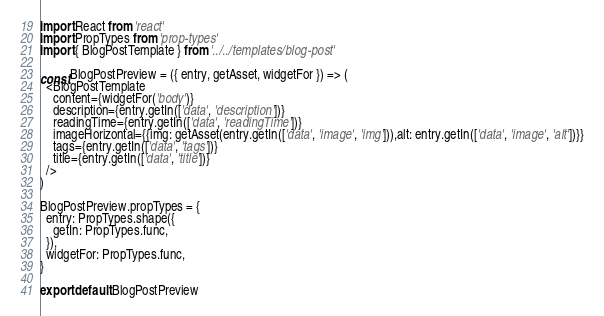<code> <loc_0><loc_0><loc_500><loc_500><_JavaScript_>import React from 'react'
import PropTypes from 'prop-types'
import { BlogPostTemplate } from '../../templates/blog-post'

const BlogPostPreview = ({ entry, getAsset, widgetFor }) => (
  <BlogPostTemplate
    content={widgetFor('body')}
    description={entry.getIn(['data', 'description'])}
    readingTime={entry.getIn(['data', 'readingTime'])}
    imageHorizontal={{img: getAsset(entry.getIn(['data', 'image', 'img'])),alt: entry.getIn(['data', 'image', 'alt'])}}
    tags={entry.getIn(['data', 'tags'])}
    title={entry.getIn(['data', 'title'])}
  />
)

BlogPostPreview.propTypes = {
  entry: PropTypes.shape({
    getIn: PropTypes.func,
  }),
  widgetFor: PropTypes.func,
}

export default BlogPostPreview
</code> 